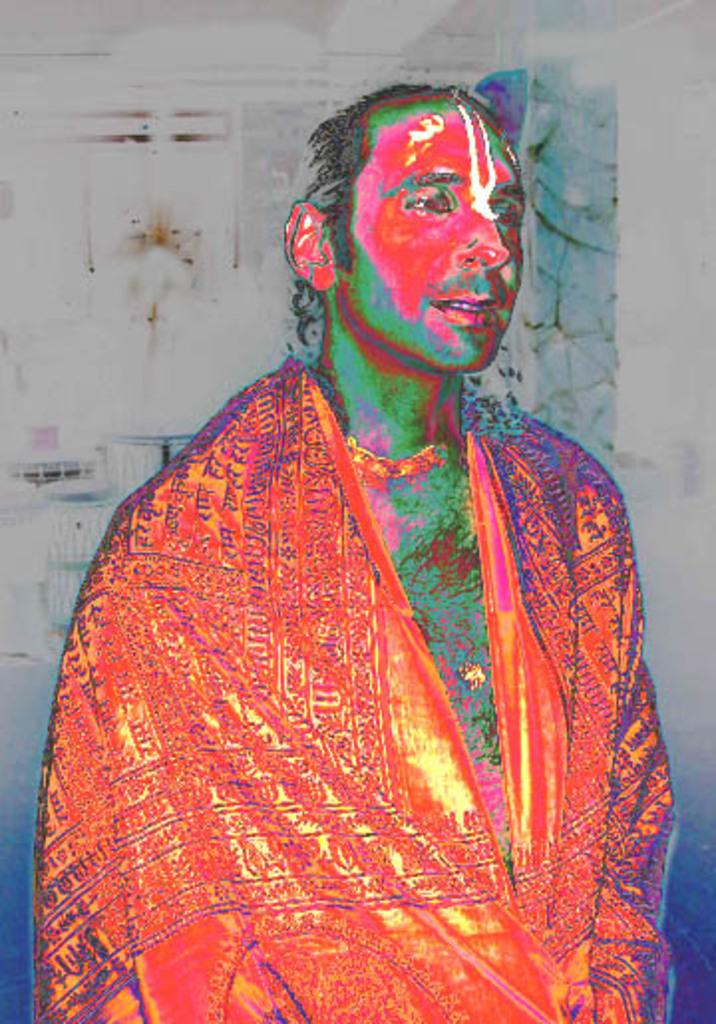What type of picture is in the image? The image contains an edited picture of a person. What is the person wearing in the image? The person is wearing an orange dress. Can you describe the background of the image? There are objects visible in the background of the image. What type of lumber is being used to support the person in the image? There is no lumber present in the image; it features an edited picture of a person wearing an orange dress. What type of grain can be seen growing in the background of the image? There is no grain visible in the image; the background contains objects, but no specific details are provided. 